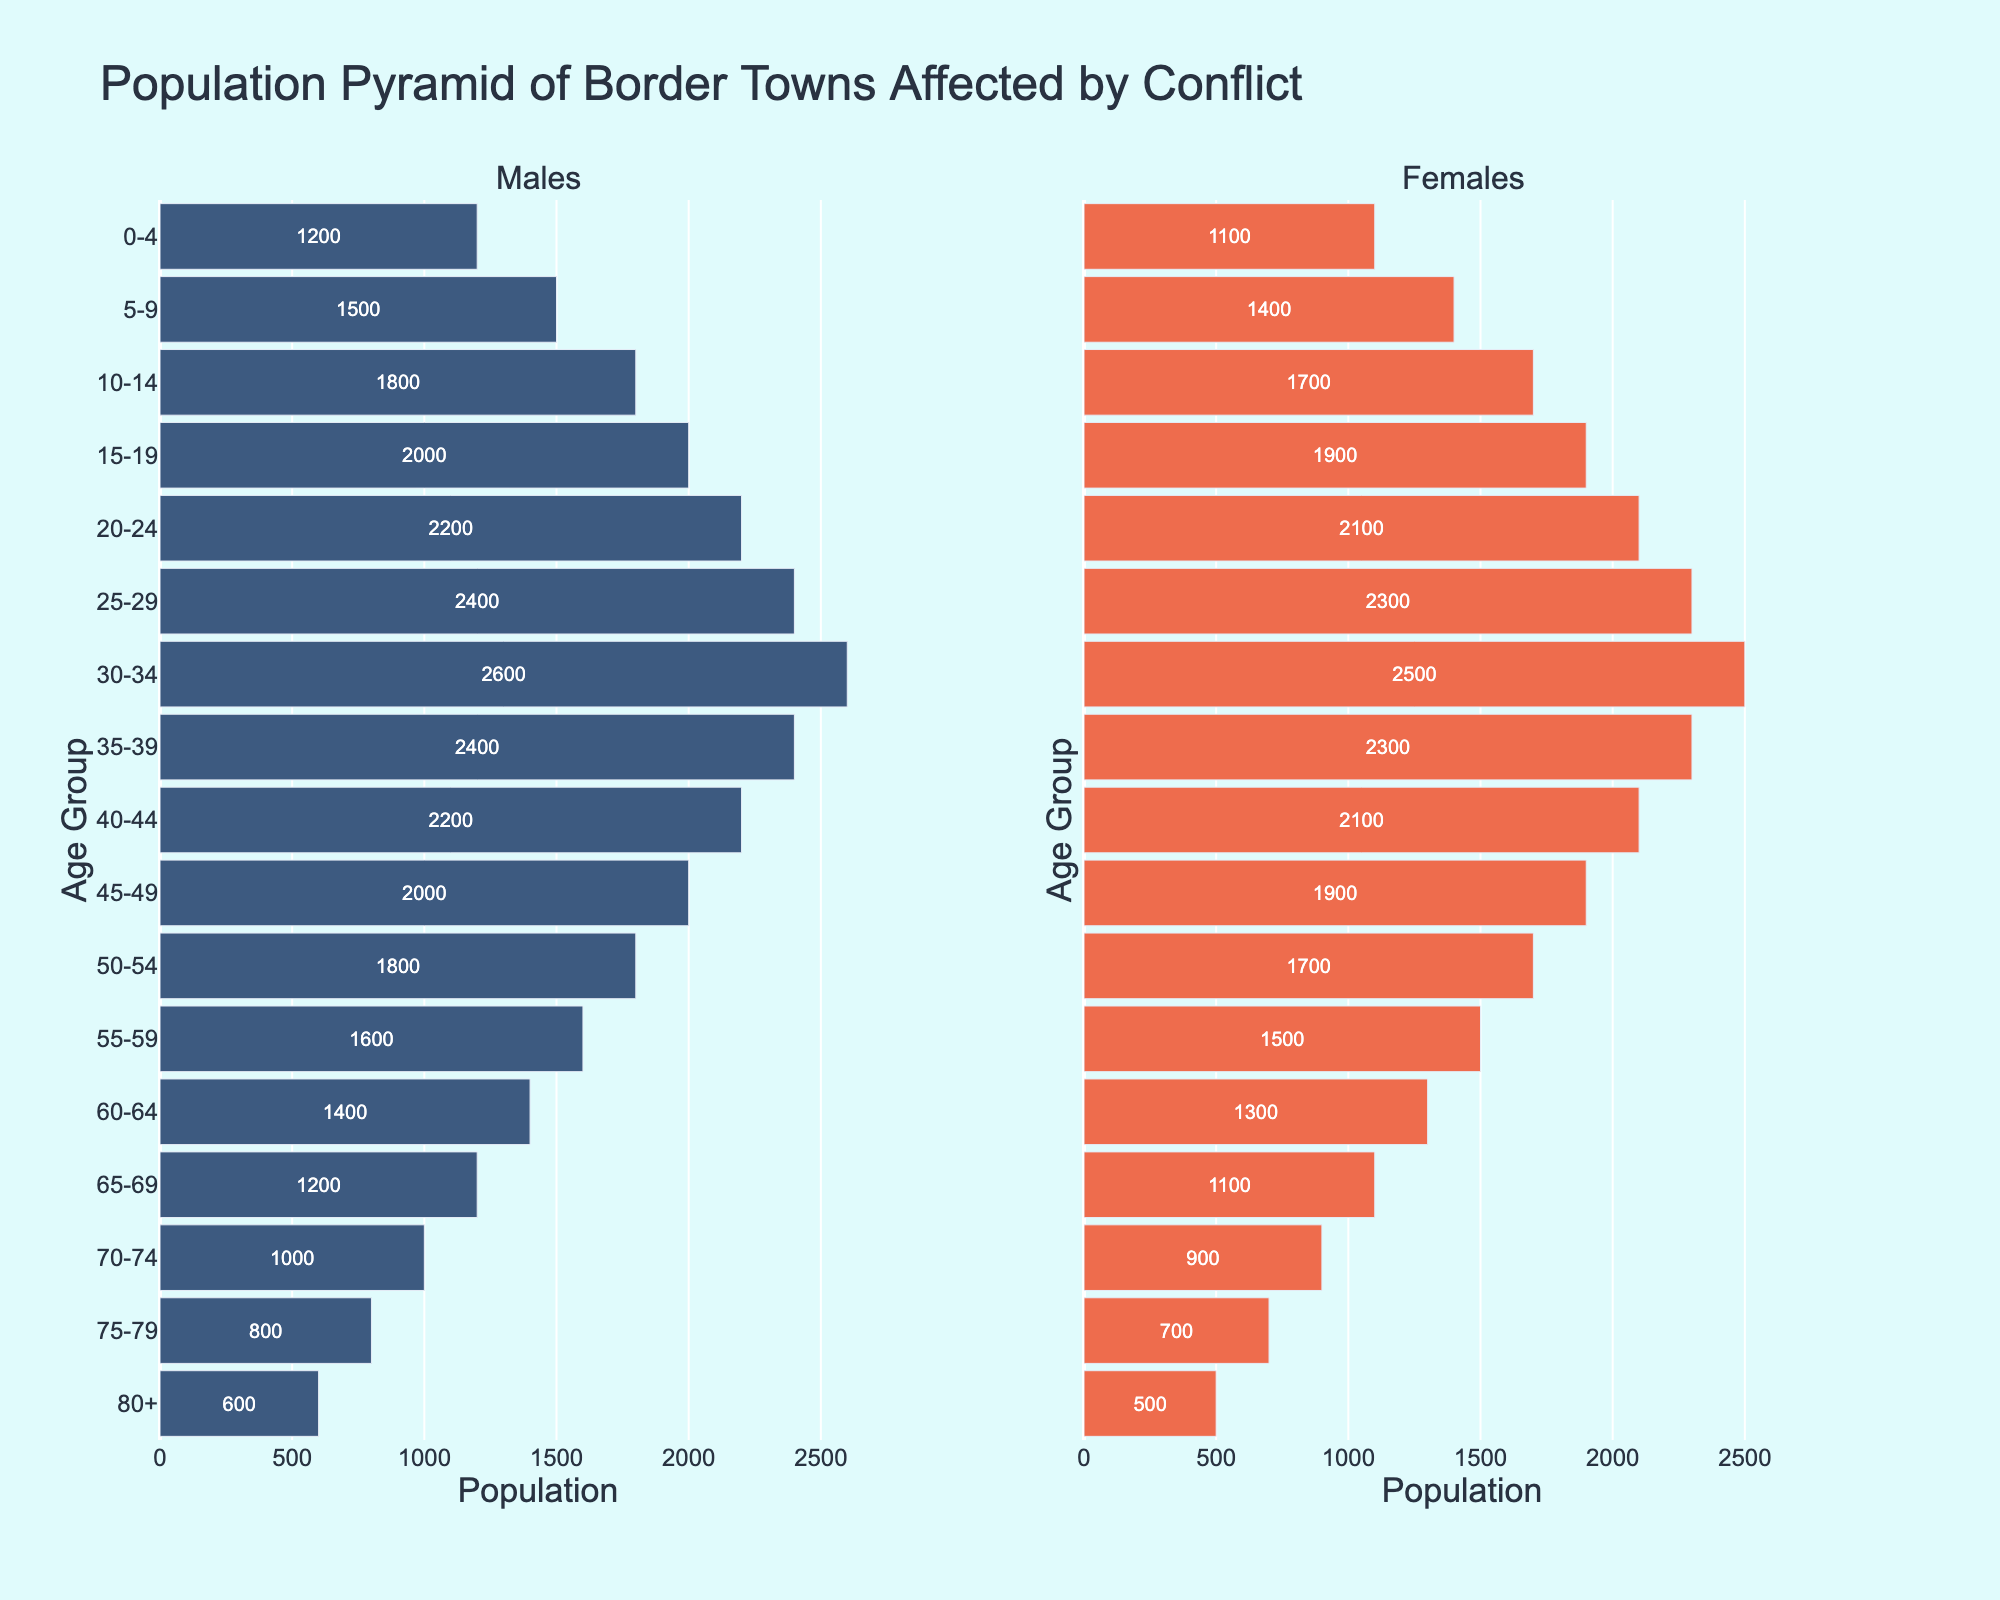What's the title of the graph? The title of the graph is located at the top center and is clearly indicated by a larger font size and distinct color.
Answer: Population Pyramid of Border Towns Affected by Conflict What age group has the largest male population? The group with the longest bar in the male section represents the largest population. Here, the age group with the longest bar (left side) is 30-34.
Answer: 30-34 Which age group shows the smallest difference between male and female populations? To determine the smallest difference, compare the lengths of bars for males and females in each age group and find the smallest difference. The smallest difference is in the 0-4 age group.
Answer: 0-4 What is the total female population in the age groups from 20-34? Add the female populations for the age groups 20-24, 25-29, and 30-34: 2100 + 2300 + 2500. The total is 6900.
Answer: 6900 Which gender has a larger population in the age group 75-79? Compare the lengths of bars for males and females in the 75-79 age group. The female bar is longer.
Answer: Females How does the population of males aged 55-59 compare to the population of females aged 55-59? Compare the population values: Males have a population of 1600 and females have 1500. Males have a larger population.
Answer: Males have a larger population What trend can you observe about the population composition as age increases? Observing the length of bars for each gender from youngest to oldest age groups, we see that the population decreases for both genders as age increases.
Answer: Population decreases with age Compare the populations of males and females aged 0-4 and 80+. Which groups have a similar population size? Compare the values for both 0-4 (Males: 1200, Females: 1100) and 80+ (Males: 600, Females: 500), noting that the populations are similar within each age group.
Answer: Both age groups have similar populations, but 0-4 is slightly larger What age range appears to be most affected by the conflict in terms of population reduction? Look for the age range where the bar lengths drastically reduce compared to adjacent groups. The significant drop happens starting at 60-64 and higher.
Answer: 60-64 and older 